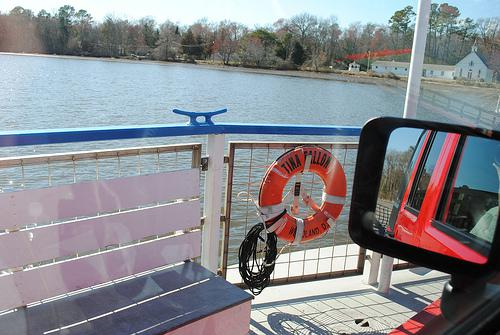Question: what color is the life preserver?
Choices:
A. Orange.
B. Red.
C. Green.
D. Blue.
Answer with the letter. Answer: A Question: where is this picture taken?
Choices:
A. A boat.
B. A surfboard.
C. A house.
D. A cave.
Answer with the letter. Answer: A 